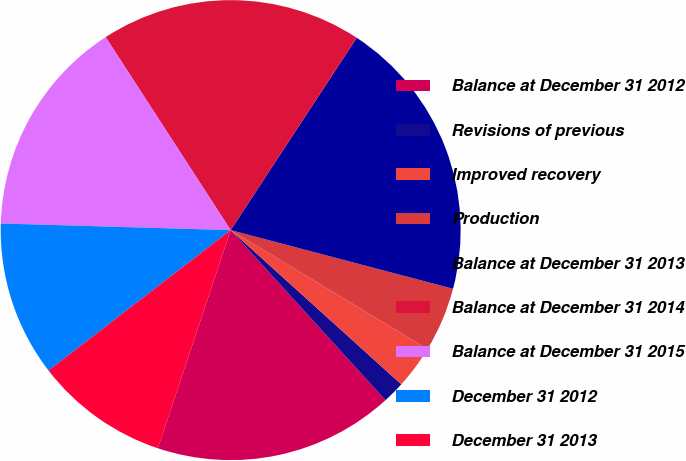Convert chart to OTSL. <chart><loc_0><loc_0><loc_500><loc_500><pie_chart><fcel>Balance at December 31 2012<fcel>Revisions of previous<fcel>Improved recovery<fcel>Production<fcel>Balance at December 31 2013<fcel>Balance at December 31 2014<fcel>Balance at December 31 2015<fcel>December 31 2012<fcel>December 31 2013<nl><fcel>16.88%<fcel>1.55%<fcel>3.05%<fcel>4.54%<fcel>19.87%<fcel>18.38%<fcel>15.39%<fcel>10.91%<fcel>9.42%<nl></chart> 